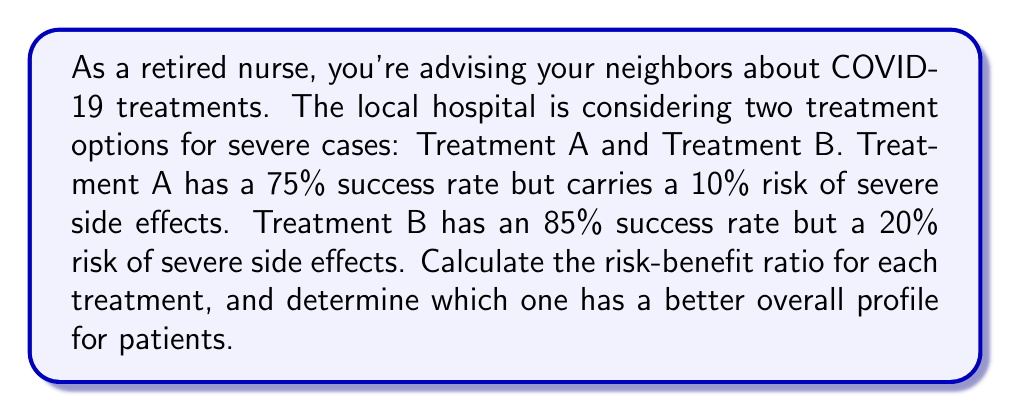Provide a solution to this math problem. To solve this problem, we need to calculate the risk-benefit ratio for each treatment option. The risk-benefit ratio is calculated by dividing the risk (probability of adverse effects) by the benefit (probability of success).

For Treatment A:
Risk = 10% = 0.10
Benefit = 75% = 0.75

Risk-Benefit Ratio (A) = $\frac{\text{Risk}}{\text{Benefit}} = \frac{0.10}{0.75} = 0.1333$

For Treatment B:
Risk = 20% = 0.20
Benefit = 85% = 0.85

Risk-Benefit Ratio (B) = $\frac{\text{Risk}}{\text{Benefit}} = \frac{0.20}{0.85} = 0.2353$

A lower risk-benefit ratio indicates a more favorable treatment option, as it means there's less risk for the given benefit.

To compare the ratios:

Treatment A: 0.1333
Treatment B: 0.2353

Since 0.1333 < 0.2353, Treatment A has a lower risk-benefit ratio and thus a better overall profile for patients.

We can also calculate the inverse of these ratios to get a benefit-risk ratio, which might be easier to interpret:

Benefit-Risk Ratio (A) = $\frac{0.75}{0.10} = 7.5$
Benefit-Risk Ratio (B) = $\frac{0.85}{0.20} = 4.25$

This shows that for every unit of risk, Treatment A provides 7.5 units of benefit, while Treatment B provides 4.25 units of benefit.
Answer: Treatment A has a risk-benefit ratio of 0.1333, while Treatment B has a risk-benefit ratio of 0.2353. Therefore, Treatment A has a better overall profile for patients. 